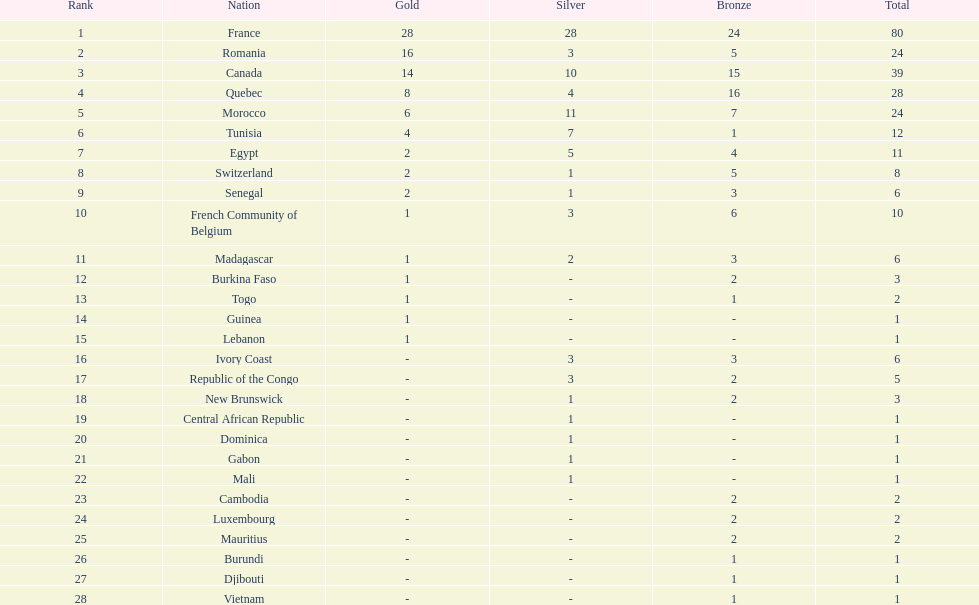Would you mind parsing the complete table? {'header': ['Rank', 'Nation', 'Gold', 'Silver', 'Bronze', 'Total'], 'rows': [['1', 'France', '28', '28', '24', '80'], ['2', 'Romania', '16', '3', '5', '24'], ['3', 'Canada', '14', '10', '15', '39'], ['4', 'Quebec', '8', '4', '16', '28'], ['5', 'Morocco', '6', '11', '7', '24'], ['6', 'Tunisia', '4', '7', '1', '12'], ['7', 'Egypt', '2', '5', '4', '11'], ['8', 'Switzerland', '2', '1', '5', '8'], ['9', 'Senegal', '2', '1', '3', '6'], ['10', 'French Community of Belgium', '1', '3', '6', '10'], ['11', 'Madagascar', '1', '2', '3', '6'], ['12', 'Burkina Faso', '1', '-', '2', '3'], ['13', 'Togo', '1', '-', '1', '2'], ['14', 'Guinea', '1', '-', '-', '1'], ['15', 'Lebanon', '1', '-', '-', '1'], ['16', 'Ivory Coast', '-', '3', '3', '6'], ['17', 'Republic of the Congo', '-', '3', '2', '5'], ['18', 'New Brunswick', '-', '1', '2', '3'], ['19', 'Central African Republic', '-', '1', '-', '1'], ['20', 'Dominica', '-', '1', '-', '1'], ['21', 'Gabon', '-', '1', '-', '1'], ['22', 'Mali', '-', '1', '-', '1'], ['23', 'Cambodia', '-', '-', '2', '2'], ['24', 'Luxembourg', '-', '-', '2', '2'], ['25', 'Mauritius', '-', '-', '2', '2'], ['26', 'Burundi', '-', '-', '1', '1'], ['27', 'Djibouti', '-', '-', '1', '1'], ['28', 'Vietnam', '-', '-', '1', '1']]} How many bronze medals does togo have? 1. 